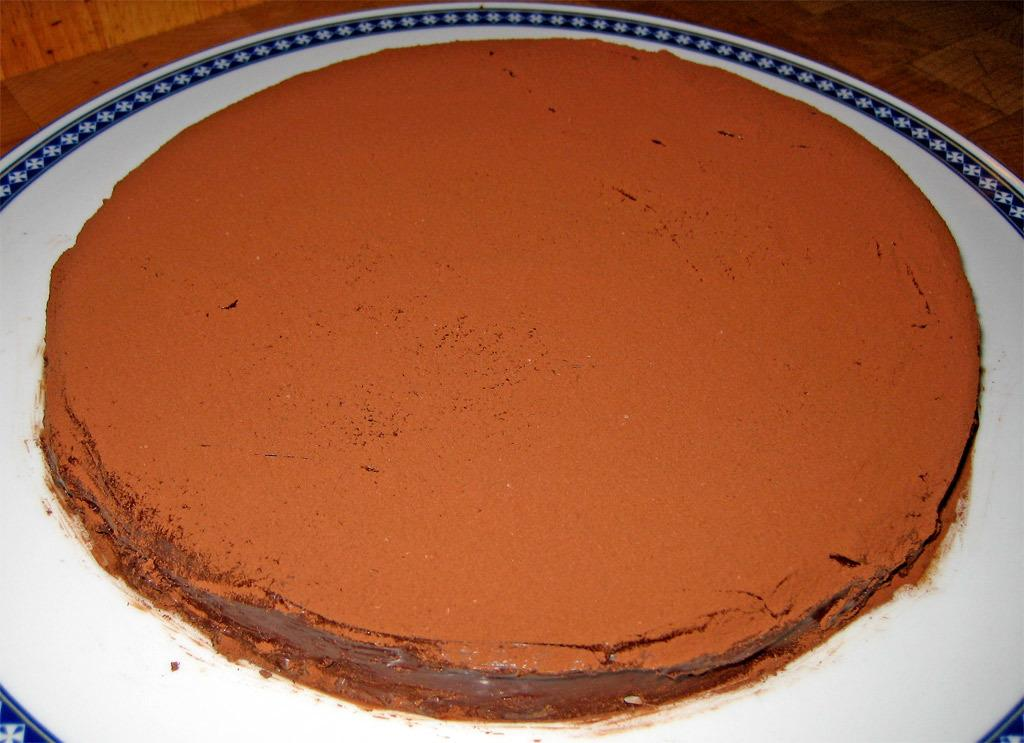What type of cake is visible in the image? There is a chocolate cake in the image. What is the chocolate cake placed on? The chocolate cake is on a white plate. What is the material of the surface the white plate is placed on? The white plate is placed on a wooden surface. What invention is being demonstrated by the zebra in the image? There is no zebra present in the image, and therefore no invention can be demonstrated. 